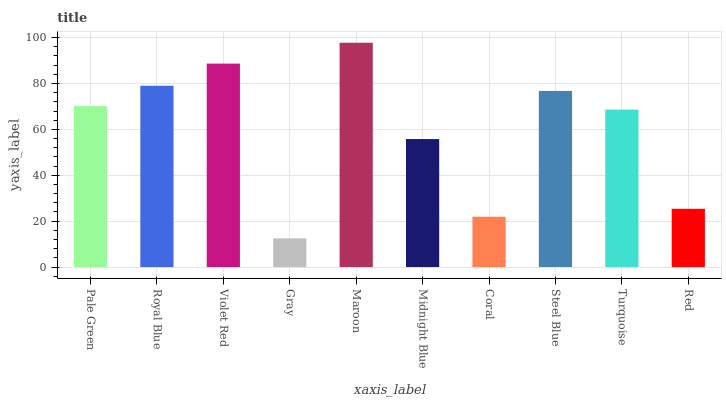Is Gray the minimum?
Answer yes or no. Yes. Is Maroon the maximum?
Answer yes or no. Yes. Is Royal Blue the minimum?
Answer yes or no. No. Is Royal Blue the maximum?
Answer yes or no. No. Is Royal Blue greater than Pale Green?
Answer yes or no. Yes. Is Pale Green less than Royal Blue?
Answer yes or no. Yes. Is Pale Green greater than Royal Blue?
Answer yes or no. No. Is Royal Blue less than Pale Green?
Answer yes or no. No. Is Pale Green the high median?
Answer yes or no. Yes. Is Turquoise the low median?
Answer yes or no. Yes. Is Royal Blue the high median?
Answer yes or no. No. Is Royal Blue the low median?
Answer yes or no. No. 